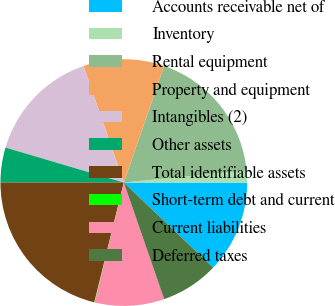Convert chart to OTSL. <chart><loc_0><loc_0><loc_500><loc_500><pie_chart><fcel>Accounts receivable net of<fcel>Inventory<fcel>Rental equipment<fcel>Property and equipment<fcel>Intangibles (2)<fcel>Other assets<fcel>Total identifiable assets<fcel>Short-term debt and current<fcel>Current liabilities<fcel>Deferred taxes<nl><fcel>12.11%<fcel>1.56%<fcel>18.14%<fcel>10.6%<fcel>15.13%<fcel>4.57%<fcel>21.16%<fcel>0.05%<fcel>9.1%<fcel>7.59%<nl></chart> 